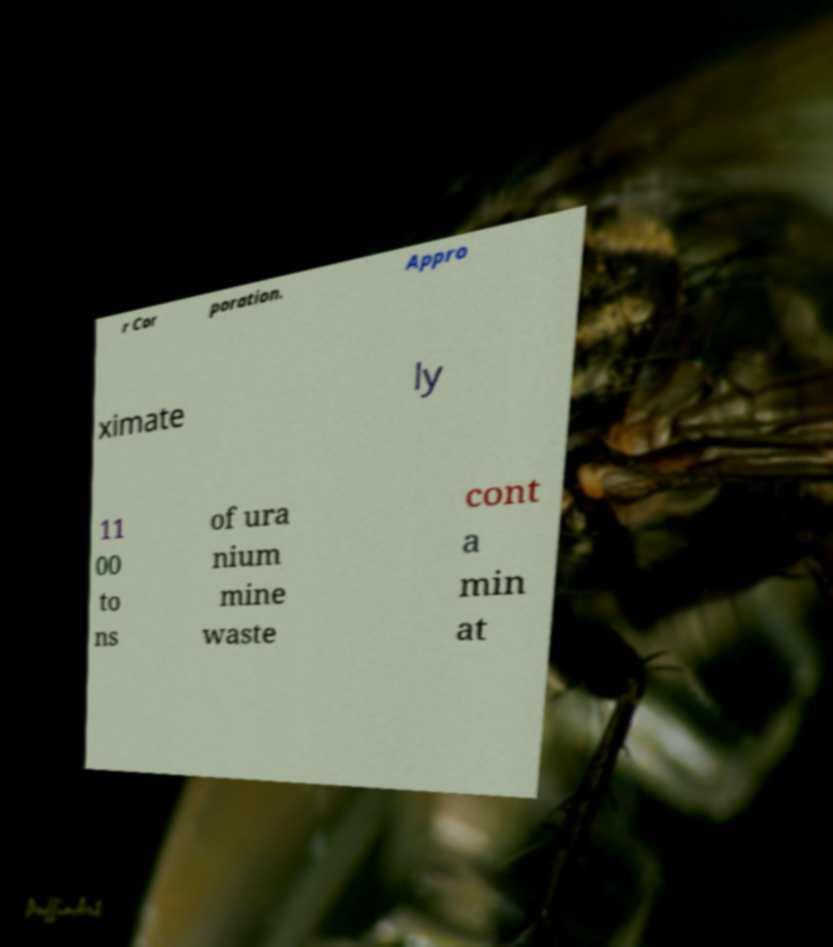What messages or text are displayed in this image? I need them in a readable, typed format. r Cor poration. Appro ximate ly 11 00 to ns of ura nium mine waste cont a min at 